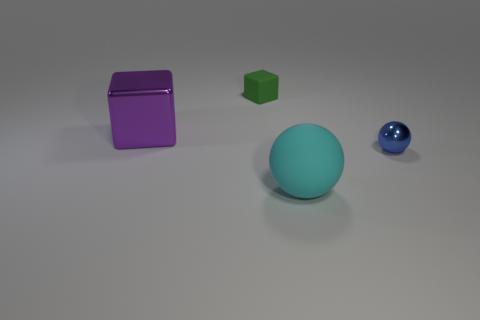Add 2 large metal things. How many objects exist? 6 Subtract all big rubber things. Subtract all purple objects. How many objects are left? 2 Add 1 large cyan matte balls. How many large cyan matte balls are left? 2 Add 3 small balls. How many small balls exist? 4 Subtract 1 purple cubes. How many objects are left? 3 